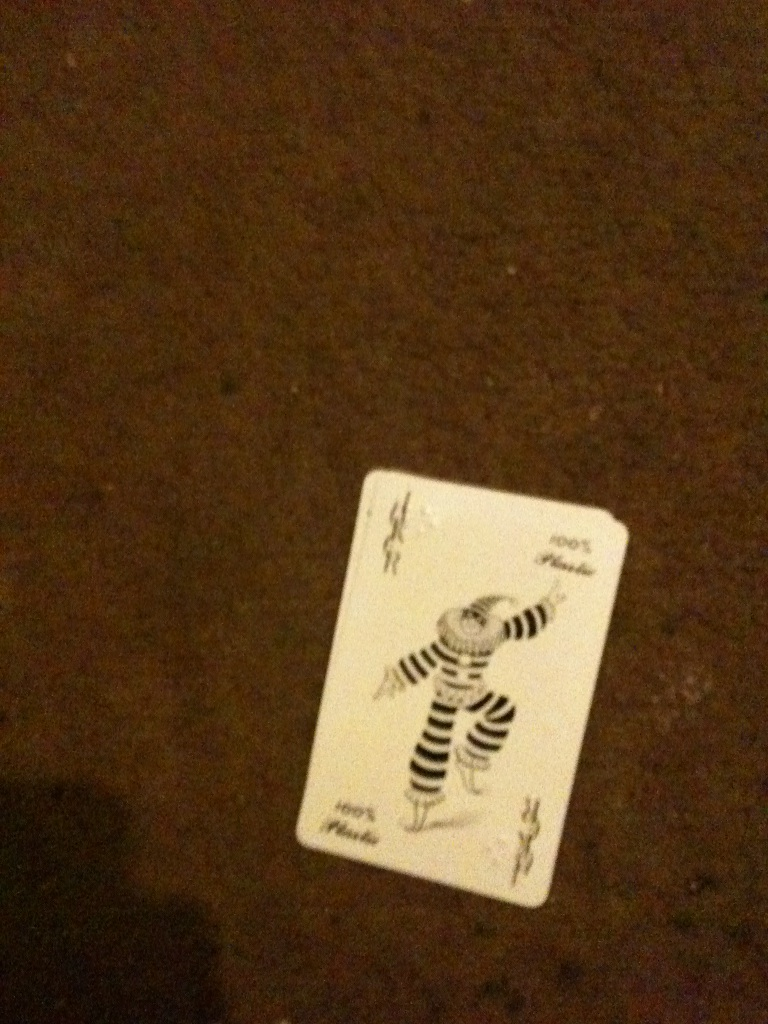What do you think the character on the Joker card is doing? The character on the Joker card is likely engaged in some form of playful or comedic pose. Considering the traditional role of a Joker or jester, this character might be in the middle of a dance, entertaining an audience with humorous antics. The animated pose, raised arm, and dynamic stance suggest movement and a lively performance. 